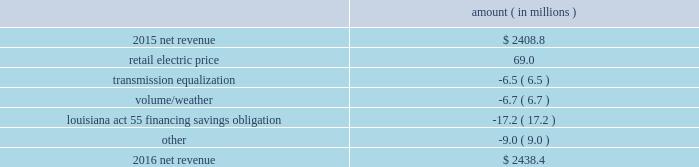Entergy louisiana , llc and subsidiaries management 2019s financial discussion and analysis results of operations net income 2016 compared to 2015 net income increased $ 175.4 million primarily due to the effect of a settlement with the irs related to the 2010-2011 irs audit , which resulted in a $ 136.1 million reduction of income tax expense .
Also contributing to the increase were lower other operation and maintenance expenses , higher net revenue , and higher other income .
The increase was partially offset by higher depreciation and amortization expenses , higher interest expense , and higher nuclear refueling outage expenses .
2015 compared to 2014 net income increased slightly , by $ 0.6 million , primarily due to higher net revenue and a lower effective income tax rate , offset by higher other operation and maintenance expenses , higher depreciation and amortization expenses , lower other income , and higher interest expense .
Net revenue 2016 compared to 2015 net revenue consists of operating revenues net of : 1 ) fuel , fuel-related expenses , and gas purchased for resale , 2 ) purchased power expenses , and 3 ) other regulatory charges .
Following is an analysis of the change in net revenue comparing 2016 to 2015 .
Amount ( in millions ) .
The retail electric price variance is primarily due to an increase in formula rate plan revenues , implemented with the first billing cycle of march 2016 , to collect the estimated first-year revenue requirement related to the purchase of power blocks 3 and 4 of the union power station .
See note 2 to the financial statements for further discussion .
The transmission equalization variance is primarily due to changes in transmission investments , including entergy louisiana 2019s exit from the system agreement in august 2016 .
The volume/weather variance is primarily due to the effect of less favorable weather on residential sales , partially offset by an increase in industrial usage and an increase in volume during the unbilled period .
The increase .
What portion of the change in net income during 2016 was related the irs audit? 
Computations: (136.1 / 175.4)
Answer: 0.77594. 